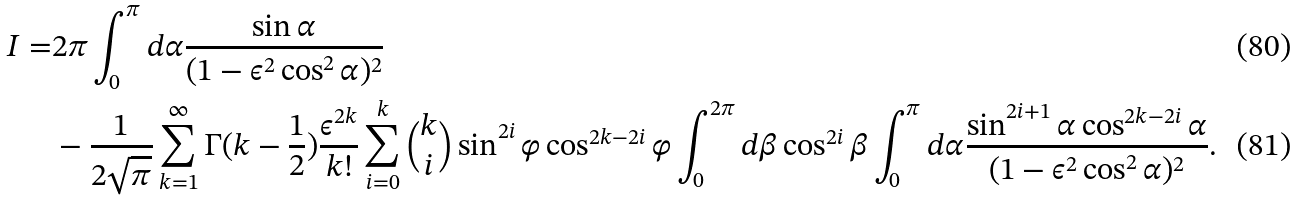<formula> <loc_0><loc_0><loc_500><loc_500>I = & 2 \pi \int _ { 0 } ^ { \pi } d \alpha \frac { \sin { \alpha } } { ( 1 - \epsilon ^ { 2 } \cos ^ { 2 } { \alpha } ) ^ { 2 } } \\ & - \frac { 1 } { 2 \sqrt { \pi } } \sum _ { k = 1 } ^ { \infty } \Gamma ( k - \frac { 1 } { 2 } ) \frac { \epsilon ^ { 2 k } } { k ! } \sum _ { i = 0 } ^ { k } \binom { k } { i } \sin ^ { 2 i } { \varphi } \cos ^ { 2 k - 2 i } { \varphi } \int _ { 0 } ^ { 2 \pi } d \beta \cos ^ { 2 i } { \beta } \int _ { 0 } ^ { \pi } d \alpha \frac { \sin ^ { 2 i + 1 } { \alpha } \cos ^ { 2 k - 2 i } { \alpha } } { ( 1 - \epsilon ^ { 2 } \cos ^ { 2 } { \alpha } ) ^ { 2 } } .</formula> 